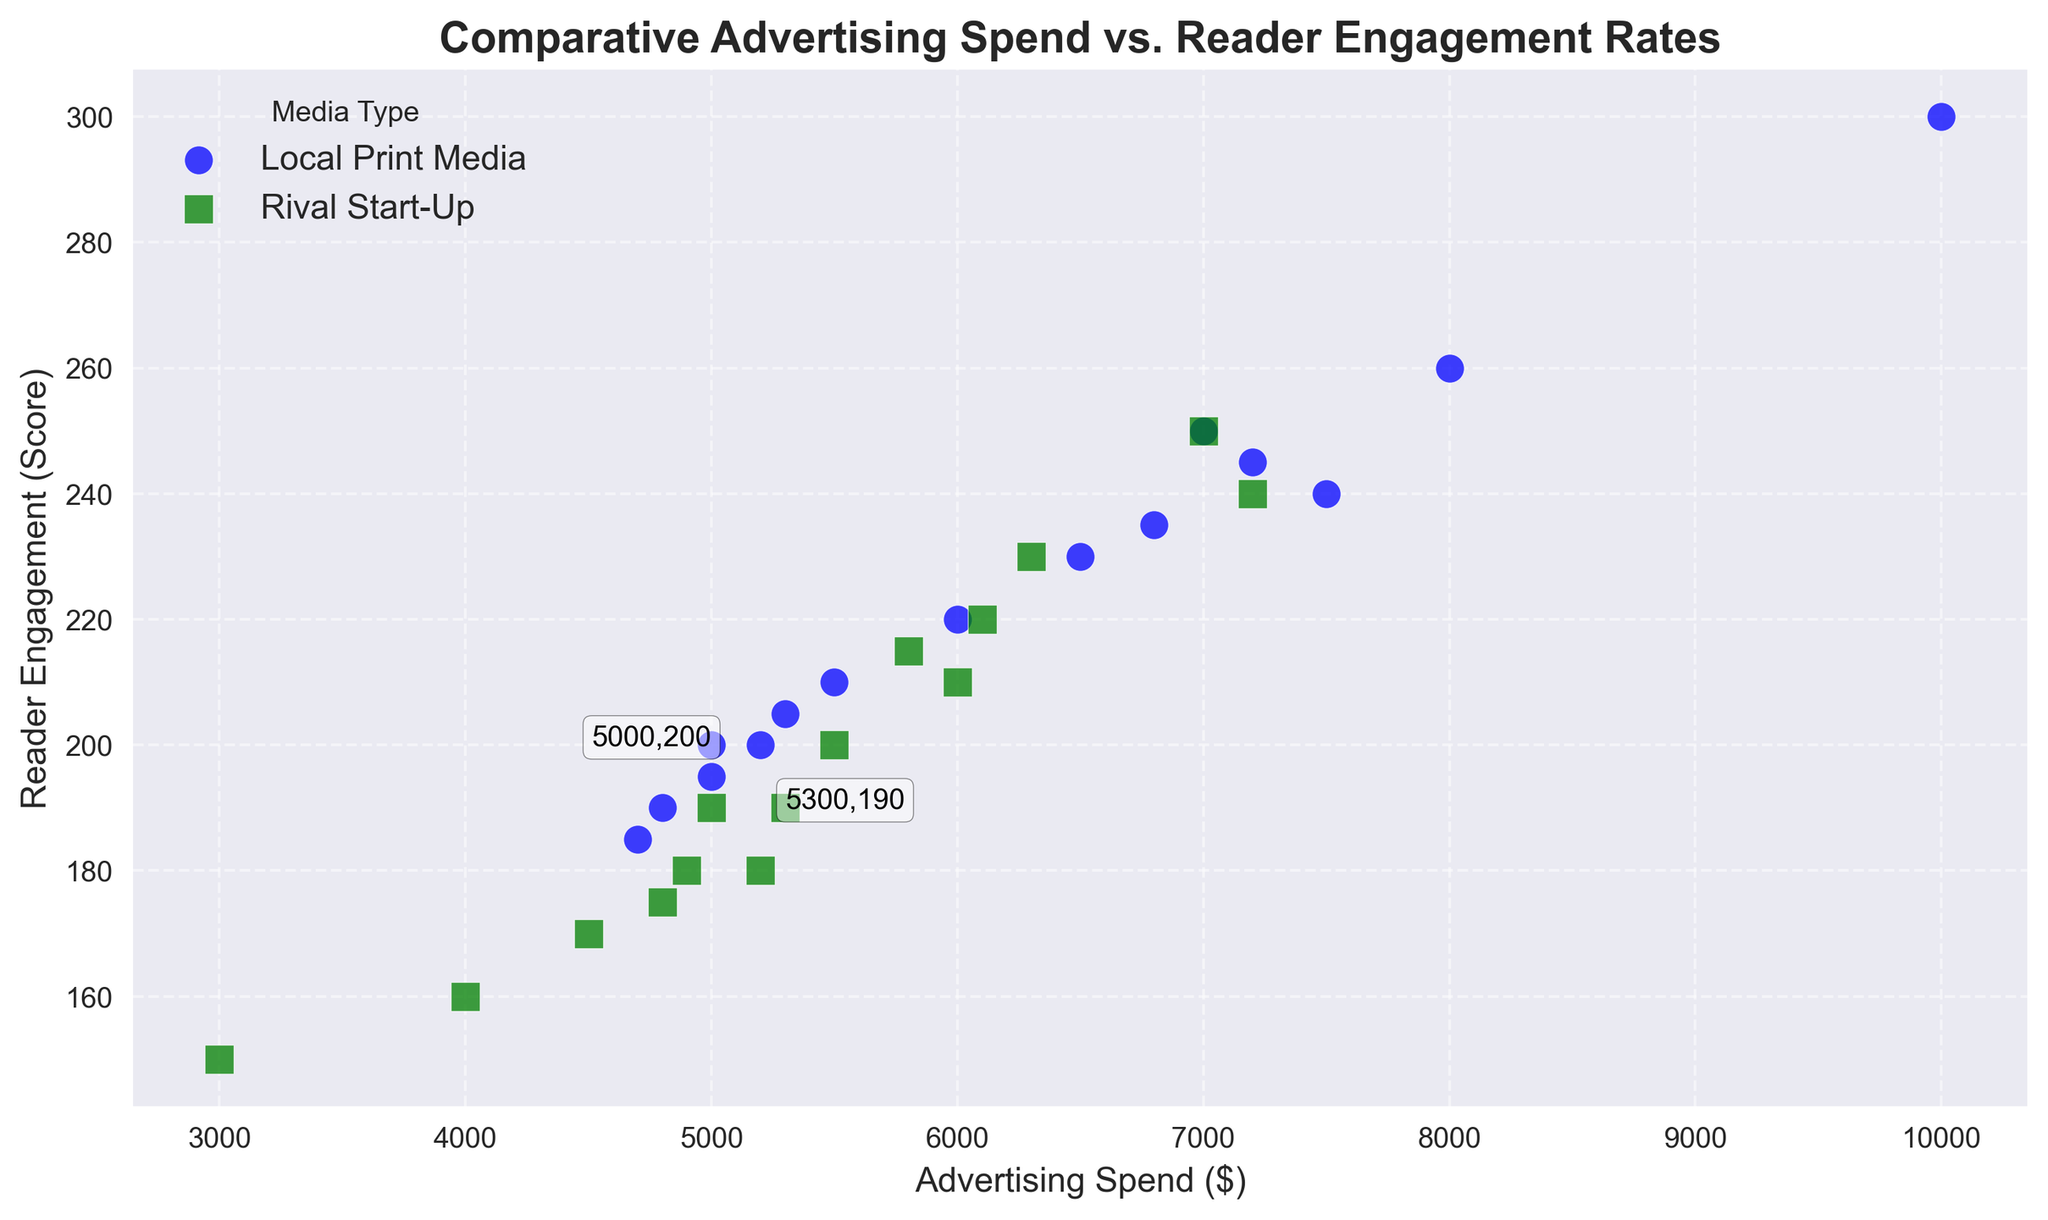Which media type generally has higher reader engagement rates for a similar range of advertising spend? By observing the scatter points, we can see that in the overlapping range of advertising spend, "Local Print Media" generally reaches higher reader engagement rates compared to "Rival Start-Up".
Answer: Local Print Media How does the reader engagement of the lowest advertising spend in Rival Start-Up compare to the highest engagement in Local Print Media? The lowest advertising spend in Rival Start-Up is $3000 with an engagement of 150. The highest engagement in Local Print Media is 300 for a spend of $10000. Thus, Local Print Media with highest engagement has much higher figures compared to the lowest engagement in Rival Start-Up.
Answer: Rival Start-Up What is the average reader engagement score for Local Print Media? First, sum up all the reader engagement scores for Local Print Media. Then divide the total by the number of entries. The total sum is 3450, divided by 15 entries.
Answer: 230 Which media type has greater engagement for an advertising spend of $5000? Looking at the visual annotations, for an advertising spend of $5000, "Local Print Media" has a reader engagement of 200, while "Rival Start-Up" has 190.
Answer: Local Print Media Compare the highest reader engagement rate in Rival Start-Up to the lowest in Local Print Media. The highest reader engagement in Rival Start-Up is 250 for $7000, while the lowest in Local Print Media is 185 for $4700. Comparing these values, 250 is higher than 185.
Answer: Rival Start-Up For both media types, identify which one has a point closer to the average advertising spend, and what the engagement score there is. Calculate the average advertising spend for both media types. The average spend for "Local Print Media" is $6460 and for "Rival Start-Up" is $5316. Closest to these averages, "Local Print Media" has a point of $6500 (Engagement: 230) and "Rival Start-Up" has $5300 (Engagement: 190).
Answer: Both What can be inferred about reader engagement at an advertising spend of $7200 for both media types? From the scatter points, "Local Print Media" has a reader engagement of 245 at $7200, while "Rival Start-Up" has an engagement score of 240. "Local Print Media" has slightly higher engagement at this spending level.
Answer: Local Print Media What's the difference in reader engagement rates for an advertising spend of $6000 between the two media types? For "Local Print Media", an advertising spend of $6000 results in an engagement of 220. For "Rival Start-Up", it is 210. The difference is 220 - 210.
Answer: 10 